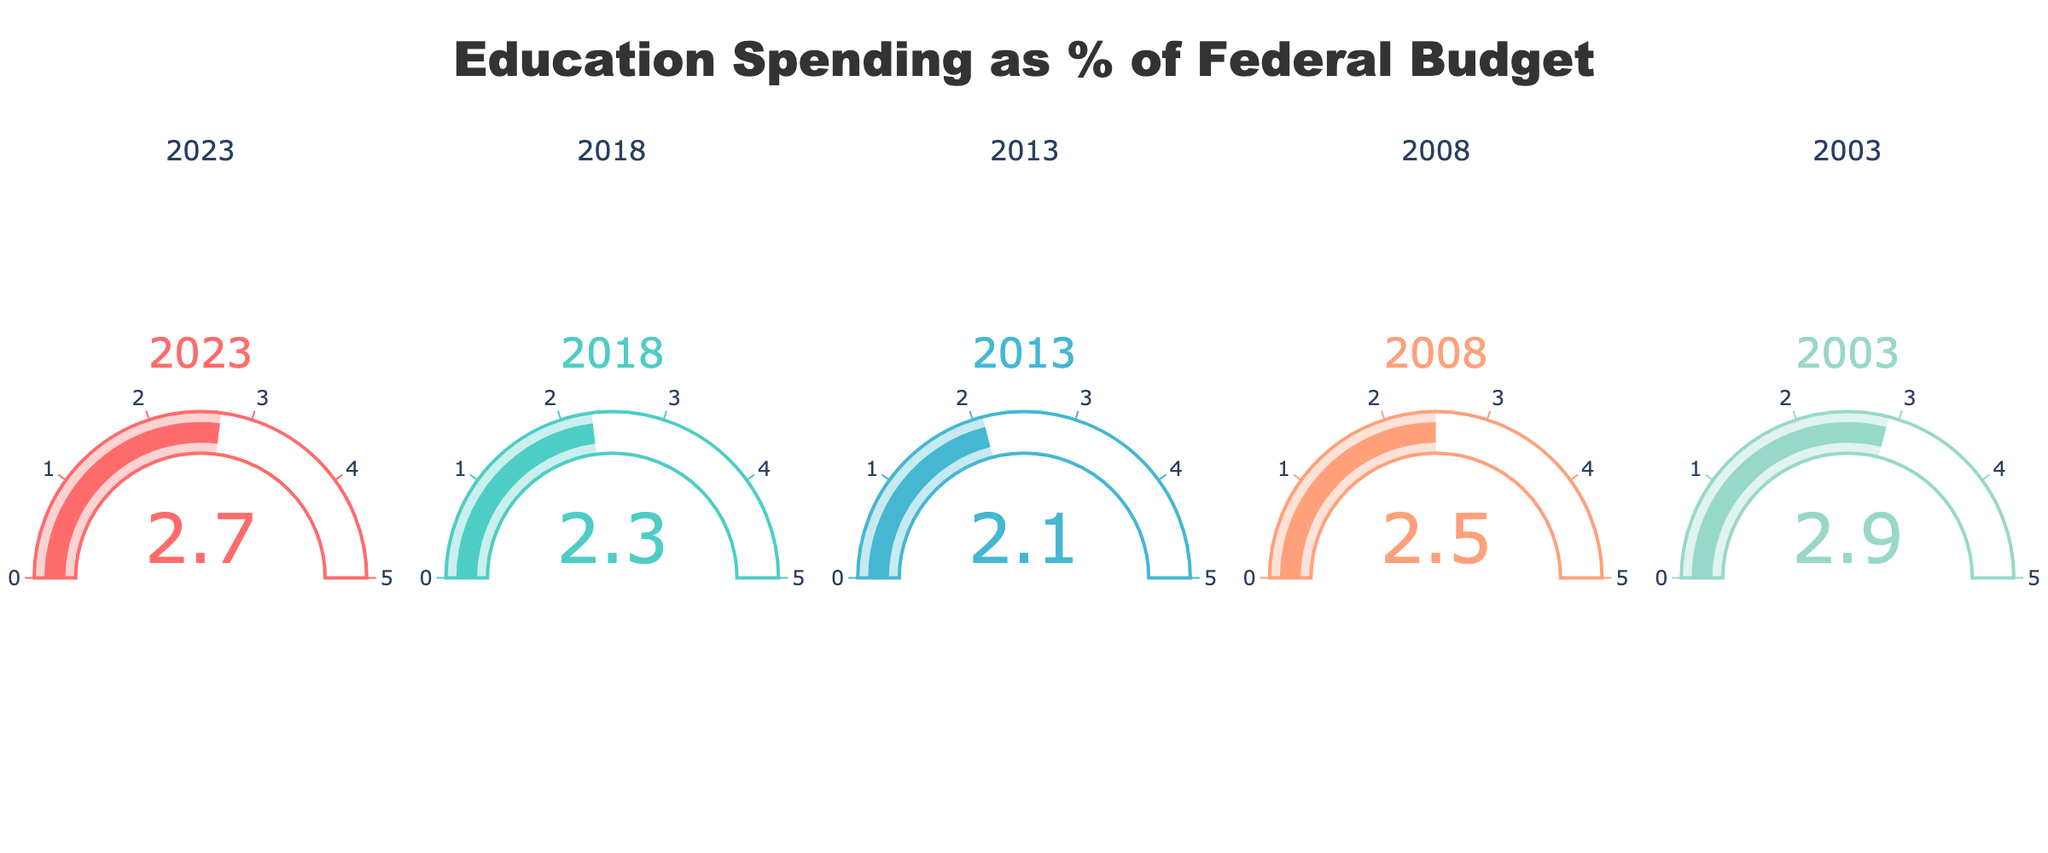What's the title of the figure? The title of the figure is located at the top center. It reads "Education Spending as % of Federal Budget."
Answer: Education Spending as % of Federal Budget How many years are represented in the figure? There are five gauges in the figure, each corresponding to a different year. This indicates that five years are represented.
Answer: 5 In which year was the percentage of the federal budget allocated to education the highest? By looking at the gauges, the year with the highest percentage is 2003, which shows a value of 2.9%.
Answer: 2003 Compare the percentage of the federal budget allocated to education in 2008 and 2018. Which year had a higher percentage? The gauge for 2008 shows 2.5%, and the gauge for 2018 shows 2.3%. Therefore, 2008 had a higher percentage.
Answer: 2008 Calculate the average percentage of the federal budget allocated to education across all the years shown. To find the average, sum all the percentages: 2.7 + 2.3 + 2.1 + 2.5 + 2.9 = 12.5. Then divide by the number of years, which is 5. So, 12.5 / 5 = 2.5%.
Answer: 2.5% Which year showed an increase in the percentage of the federal budget allocated to education compared to the previous recorded year? Comparing each year to the one before it: from 2013 to 2018, the percentage increased from 2.1% to 2.3%.
Answer: 2018 Rank the years in descending order based on the percentage of the federal budget allocated to education. Listing the percentages in descending order: 2.9% (2003), 2.7% (2023), 2.5% (2008), 2.3% (2018), 2.1% (2013). Therefore, the ranking is 2003, 2023, 2008, 2018, 2013.
Answer: 2003, 2023, 2008, 2018, 2013 What color is used to represent the year 2023? The gauge for 2023 is colored pinkish-red, which can be described as coral red.
Answer: Coral red What's the percentage change in the federal budget allocated to education from 2003 to 2013? To calculate percentage change: ((2.1 - 2.9) / 2.9) * 100% = (-0.8 / 2.9) * 100% ≈ -27.59%.
Answer: -27.59% What is the range of the gauge values? The gauges span from 0 to 5, as indicated by the number markings on each axis.
Answer: 0 to 5 